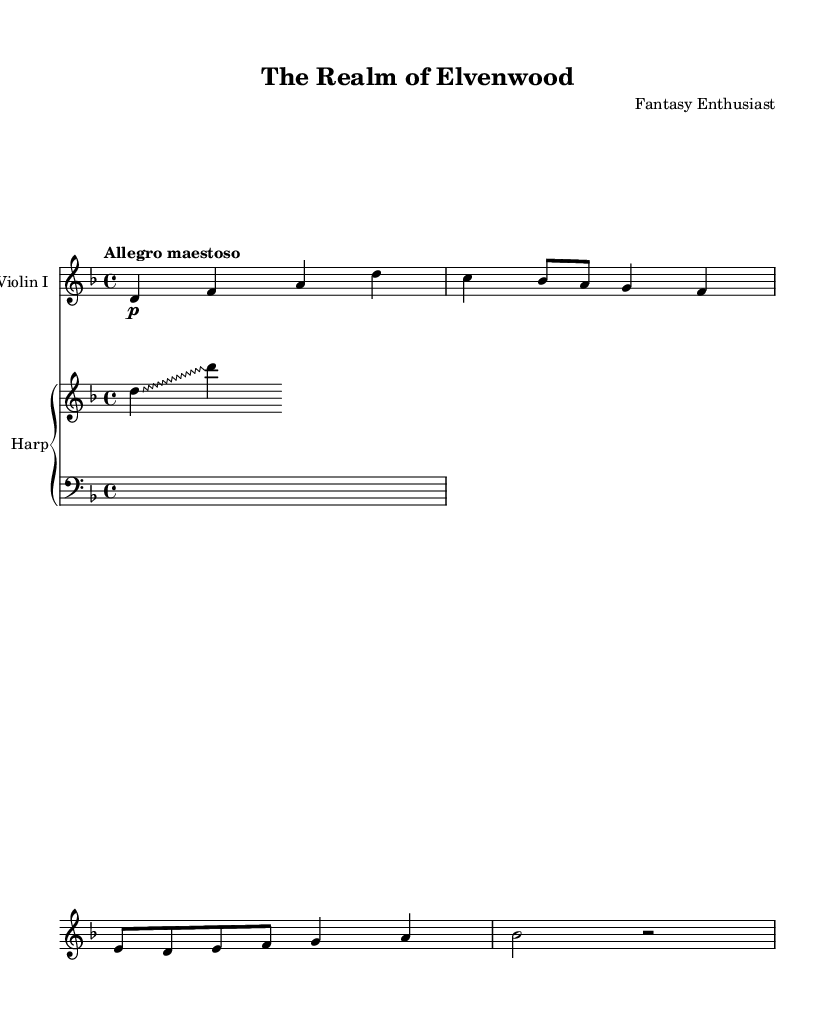What is the key signature of this music? The key signature is shown at the beginning of the staff, and it indicates D minor, which has one flat (B flat).
Answer: D minor What is the time signature of this piece? The time signature is located at the beginning of the music, indicated as 4/4, meaning there are four beats in each measure and a quarter note receives one beat.
Answer: 4/4 What is the tempo marking for this composition? The tempo marking is found above the staff and indicates the speed of the piece as "Allegro maestoso," which suggests a fast and majestic pace.
Answer: Allegro maestoso How many measures does the violin part contain? To determine this, we count the number of bar lines in the violin part. The provided music has five measures total.
Answer: Five What type of glissando technique is written for the harp? In the harp part, the notation shows a zigzag glissando, indicated by the specific override command in the code.
Answer: Zigzag Why is there silence in the bass part of the piano staff? The bass staff has a whole measure rest (notated as "s1"), indicating that there is no sound produced in that measure, reflecting an intentional pause in the composition.
Answer: Rest 